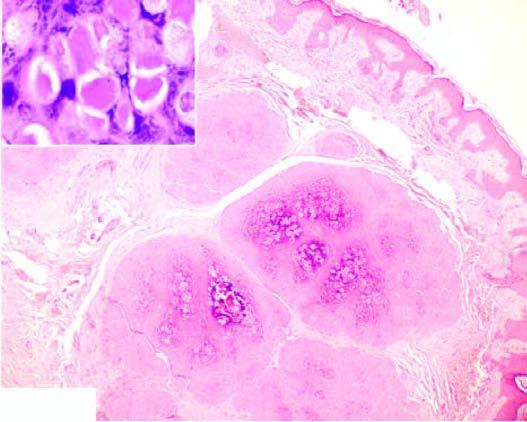what does inset show?
Answer the question using a single word or phrase. Close-up view of molluscum bodies 